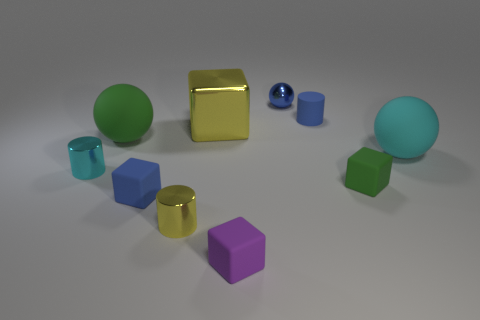Subtract all blue rubber cylinders. How many cylinders are left? 2 Subtract all blue cylinders. How many cylinders are left? 2 Subtract 2 cubes. How many cubes are left? 2 Subtract all blocks. How many objects are left? 6 Add 5 blue rubber objects. How many blue rubber objects are left? 7 Add 4 blue matte cubes. How many blue matte cubes exist? 5 Subtract 0 cyan blocks. How many objects are left? 10 Subtract all purple cylinders. Subtract all cyan cubes. How many cylinders are left? 3 Subtract all yellow spheres. How many cyan cylinders are left? 1 Subtract all large yellow blocks. Subtract all spheres. How many objects are left? 6 